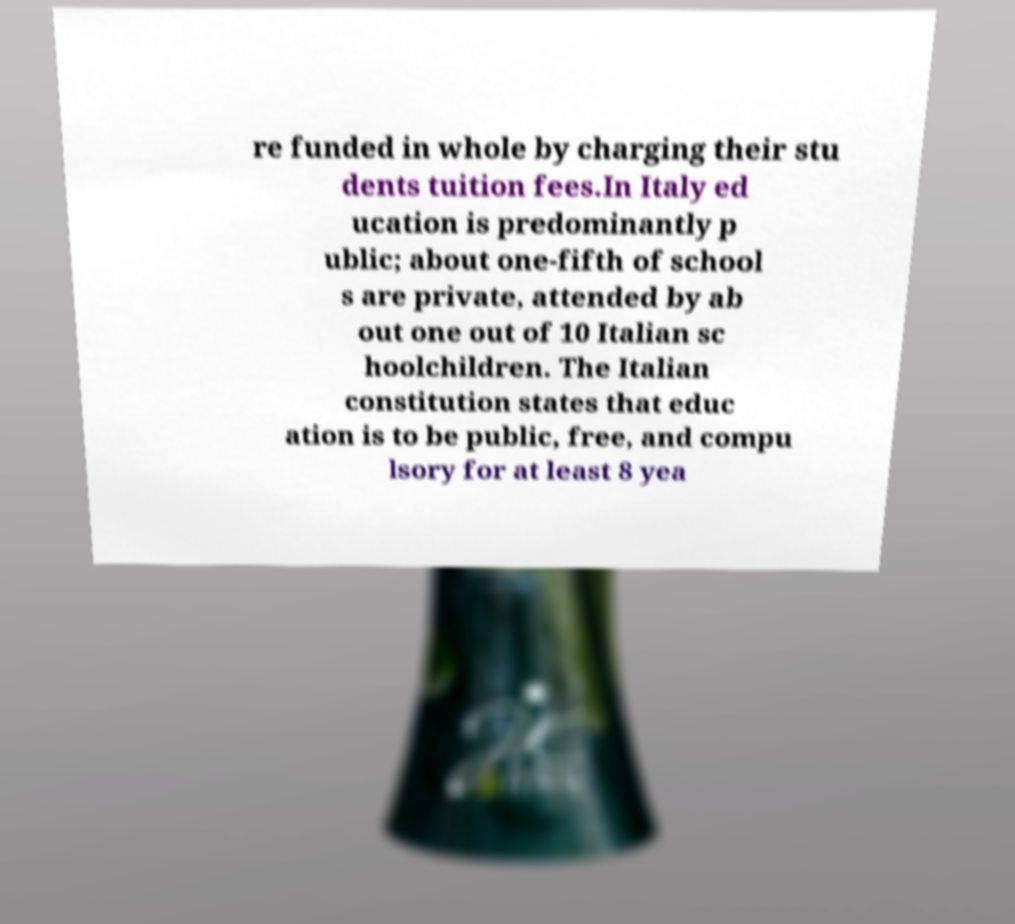For documentation purposes, I need the text within this image transcribed. Could you provide that? re funded in whole by charging their stu dents tuition fees.In Italy ed ucation is predominantly p ublic; about one-fifth of school s are private, attended by ab out one out of 10 Italian sc hoolchildren. The Italian constitution states that educ ation is to be public, free, and compu lsory for at least 8 yea 